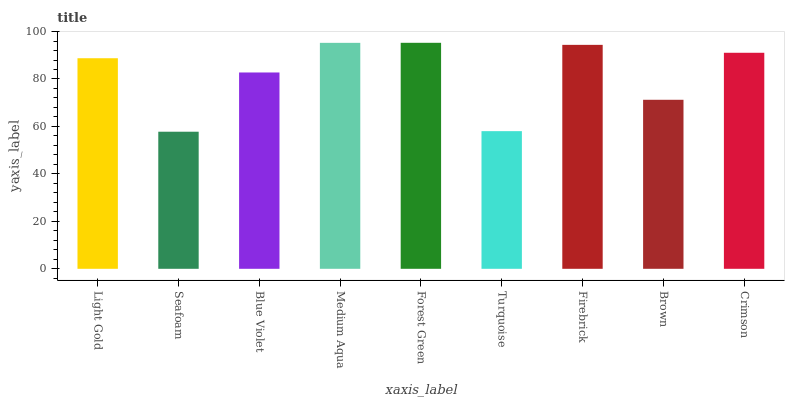Is Seafoam the minimum?
Answer yes or no. Yes. Is Forest Green the maximum?
Answer yes or no. Yes. Is Blue Violet the minimum?
Answer yes or no. No. Is Blue Violet the maximum?
Answer yes or no. No. Is Blue Violet greater than Seafoam?
Answer yes or no. Yes. Is Seafoam less than Blue Violet?
Answer yes or no. Yes. Is Seafoam greater than Blue Violet?
Answer yes or no. No. Is Blue Violet less than Seafoam?
Answer yes or no. No. Is Light Gold the high median?
Answer yes or no. Yes. Is Light Gold the low median?
Answer yes or no. Yes. Is Turquoise the high median?
Answer yes or no. No. Is Seafoam the low median?
Answer yes or no. No. 